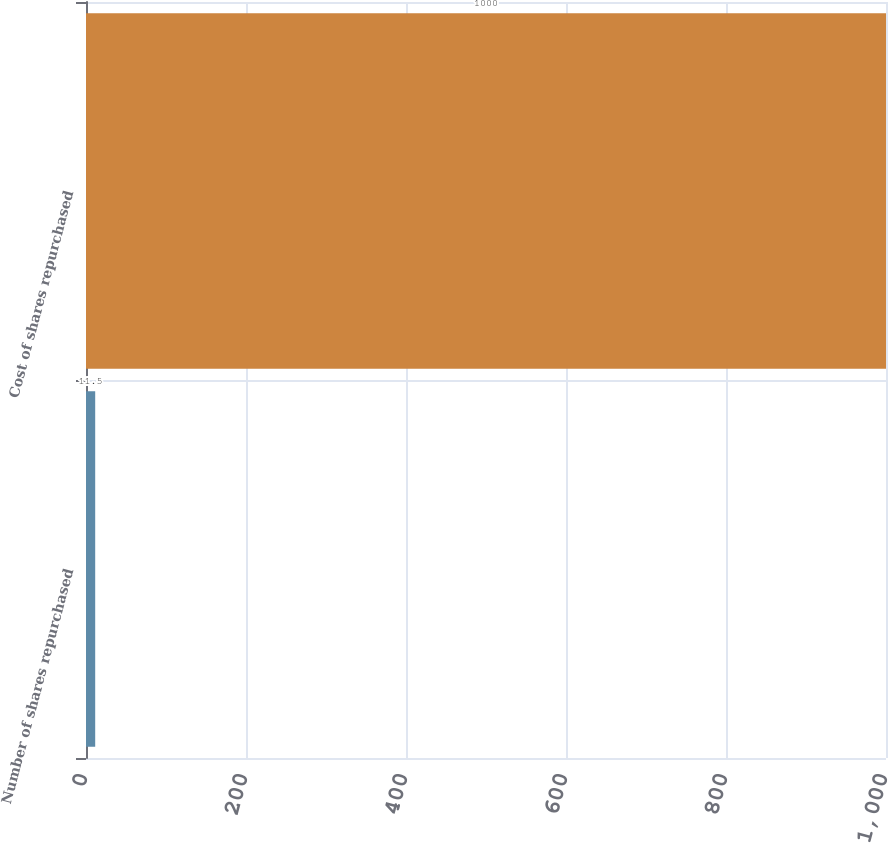Convert chart to OTSL. <chart><loc_0><loc_0><loc_500><loc_500><bar_chart><fcel>Number of shares repurchased<fcel>Cost of shares repurchased<nl><fcel>11.5<fcel>1000<nl></chart> 